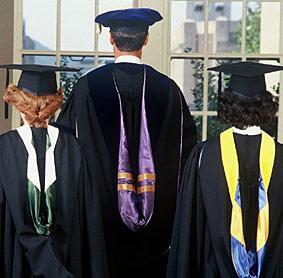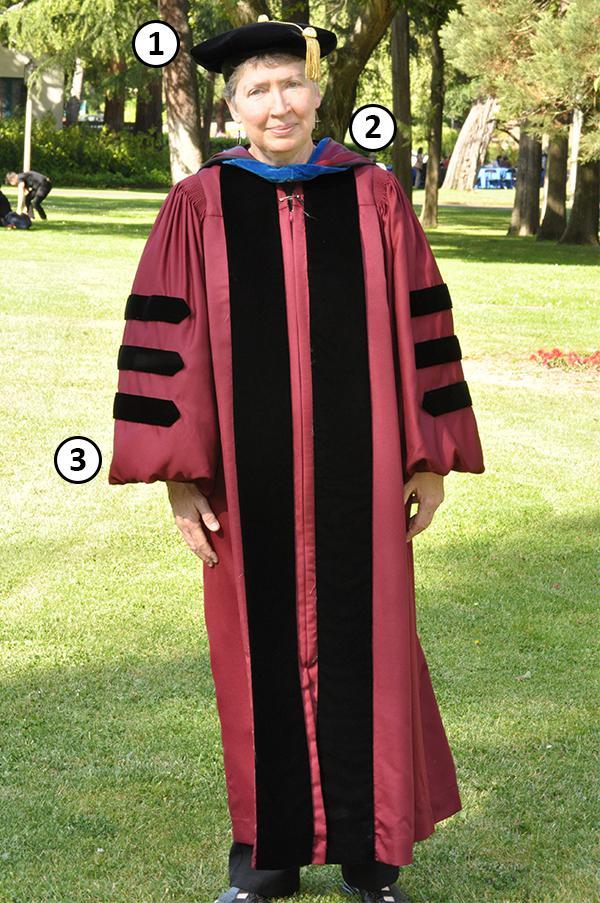The first image is the image on the left, the second image is the image on the right. Assess this claim about the two images: "In each image, a woman with long dark hair is wearing a black graduation gown and mortarboard and black shoes in an outdoor setting.". Correct or not? Answer yes or no. No. The first image is the image on the left, the second image is the image on the right. Evaluate the accuracy of this statement regarding the images: "A single male is posing in graduation attire in the image on the right.". Is it true? Answer yes or no. Yes. 